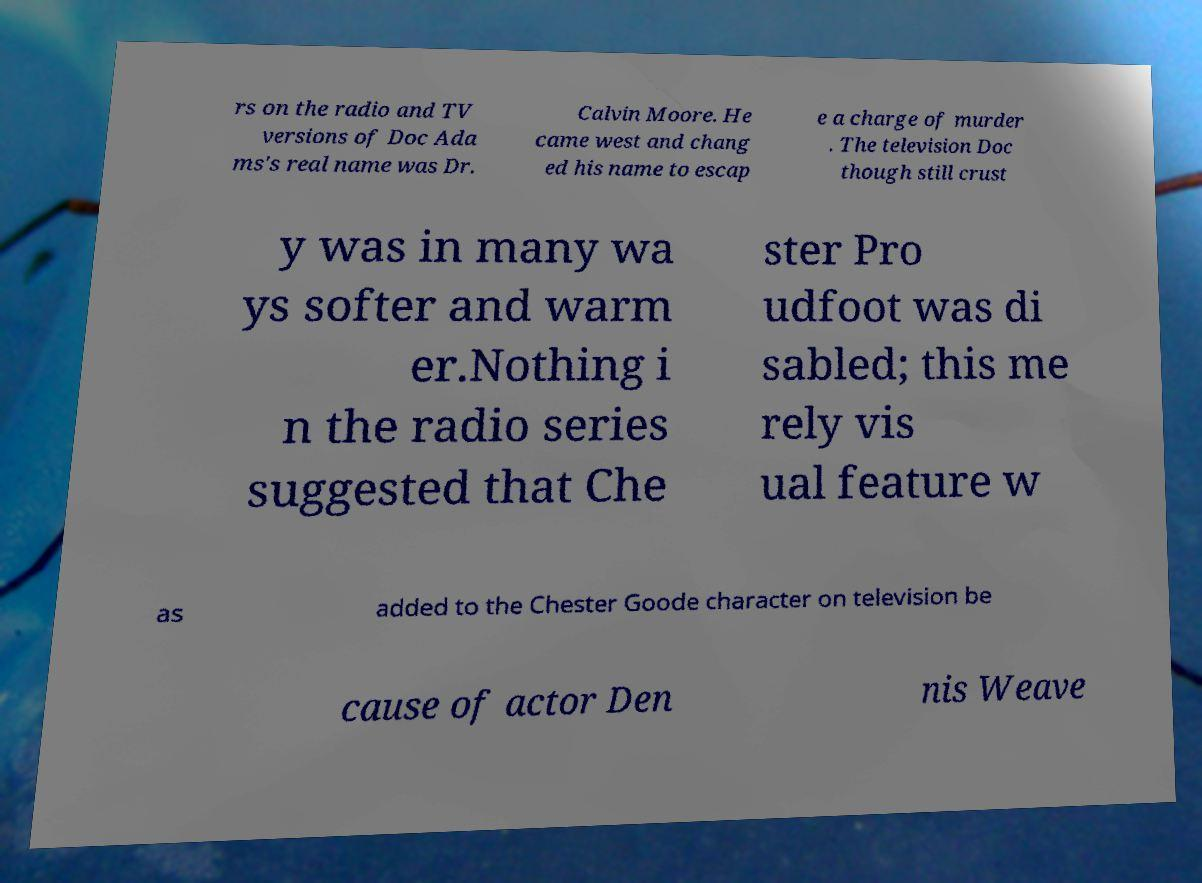What messages or text are displayed in this image? I need them in a readable, typed format. rs on the radio and TV versions of Doc Ada ms's real name was Dr. Calvin Moore. He came west and chang ed his name to escap e a charge of murder . The television Doc though still crust y was in many wa ys softer and warm er.Nothing i n the radio series suggested that Che ster Pro udfoot was di sabled; this me rely vis ual feature w as added to the Chester Goode character on television be cause of actor Den nis Weave 